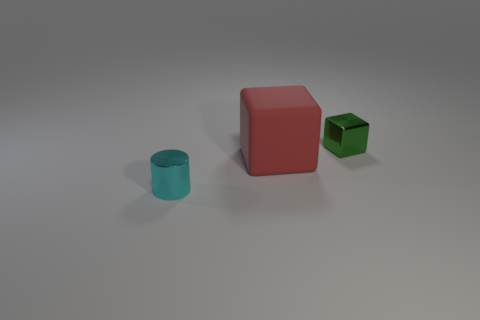Add 1 cyan shiny objects. How many objects exist? 4 Add 2 tiny cyan metallic objects. How many tiny cyan metallic objects are left? 3 Add 2 tiny cylinders. How many tiny cylinders exist? 3 Subtract 0 yellow blocks. How many objects are left? 3 Subtract all cubes. How many objects are left? 1 Subtract all blue cubes. Subtract all gray cylinders. How many cubes are left? 2 Subtract all cyan spheres. How many green cubes are left? 1 Subtract all tiny red rubber spheres. Subtract all blocks. How many objects are left? 1 